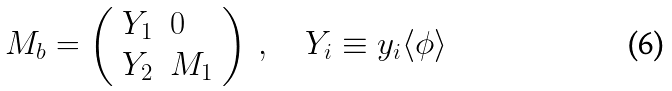Convert formula to latex. <formula><loc_0><loc_0><loc_500><loc_500>M _ { b } = \left ( \begin{array} { l l } { { Y _ { 1 } } } & { 0 } \\ { { Y _ { 2 } } } & { { M _ { 1 } } } \end{array} \right ) \ , \quad Y _ { i } \equiv y _ { i } \langle \phi \rangle</formula> 